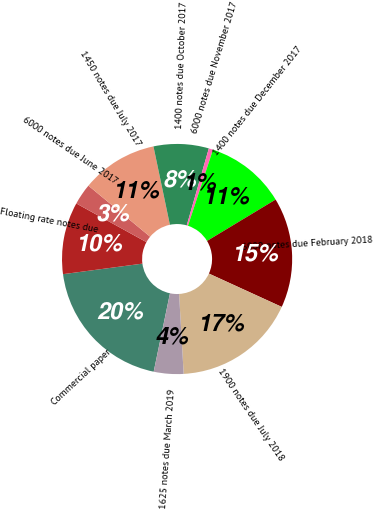Convert chart. <chart><loc_0><loc_0><loc_500><loc_500><pie_chart><fcel>Commercial paper<fcel>Floating rate notes due<fcel>6000 notes due June 2017<fcel>1450 notes due July 2017<fcel>1400 notes due October 2017<fcel>6000 notes due November 2017<fcel>1400 notes due December 2017<fcel>6000 notes due February 2018<fcel>1900 notes due July 2018<fcel>1625 notes due March 2019<nl><fcel>19.64%<fcel>10.12%<fcel>2.98%<fcel>10.71%<fcel>7.74%<fcel>0.6%<fcel>11.31%<fcel>15.47%<fcel>17.26%<fcel>4.17%<nl></chart> 